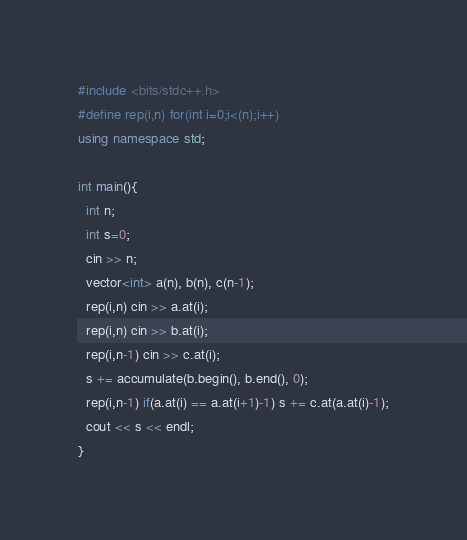Convert code to text. <code><loc_0><loc_0><loc_500><loc_500><_C++_>#include <bits/stdc++.h>
#define rep(i,n) for(int i=0;i<(n);i++)
using namespace std;
 
int main(){
  int n;
  int s=0;
  cin >> n;
  vector<int> a(n), b(n), c(n-1);
  rep(i,n) cin >> a.at(i);
  rep(i,n) cin >> b.at(i);
  rep(i,n-1) cin >> c.at(i);
  s += accumulate(b.begin(), b.end(), 0);
  rep(i,n-1) if(a.at(i) == a.at(i+1)-1) s += c.at(a.at(i)-1);
  cout << s << endl;
}</code> 